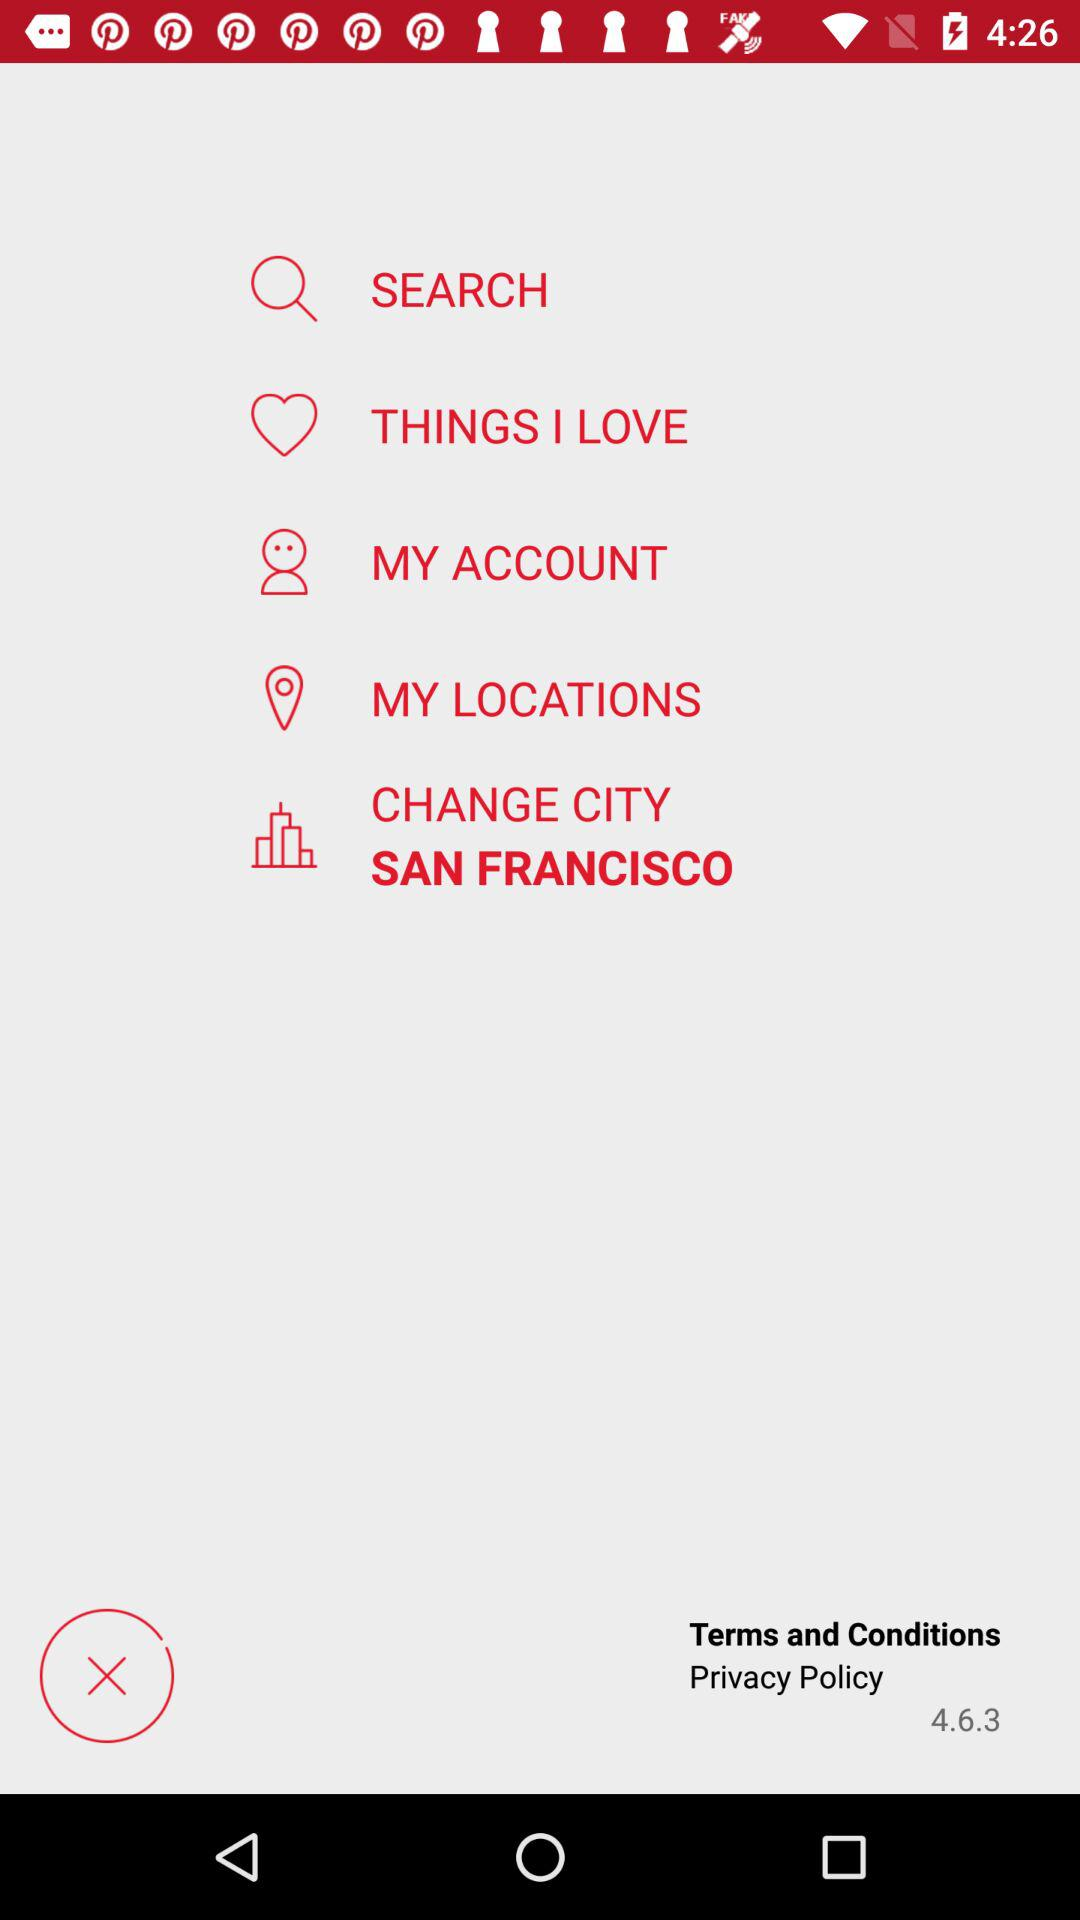Which city is selected? The selected city is Croatia. 